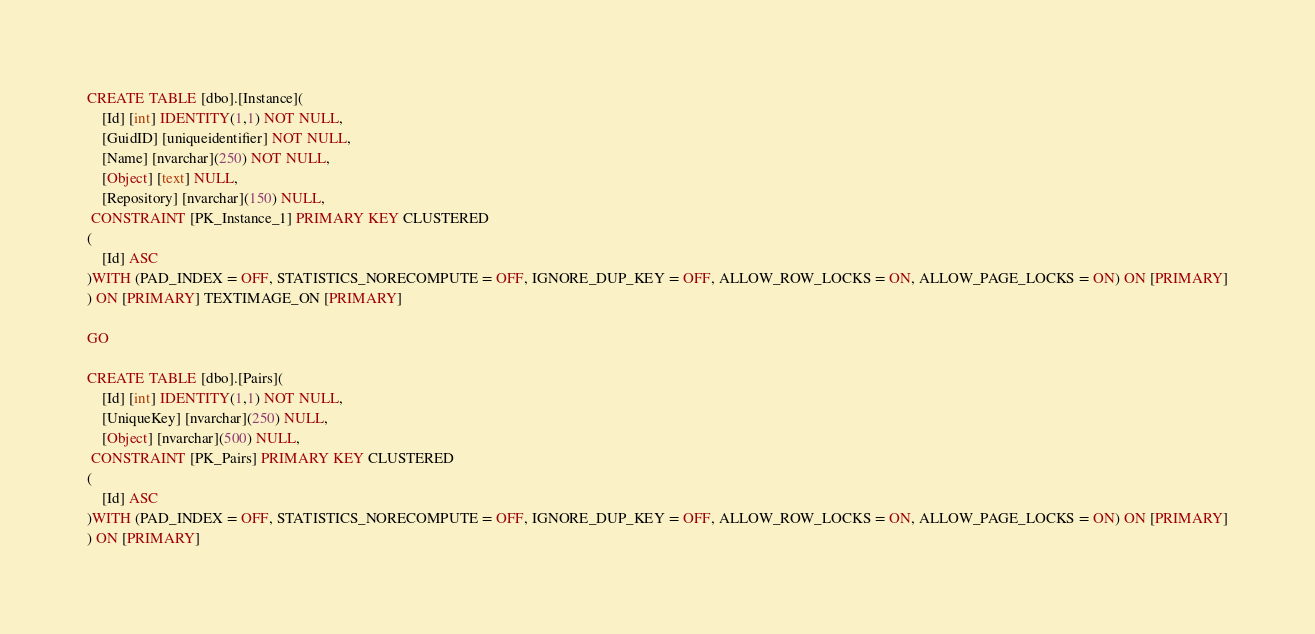Convert code to text. <code><loc_0><loc_0><loc_500><loc_500><_SQL_>CREATE TABLE [dbo].[Instance](
	[Id] [int] IDENTITY(1,1) NOT NULL,
	[GuidID] [uniqueidentifier] NOT NULL,
	[Name] [nvarchar](250) NOT NULL,
	[Object] [text] NULL,
	[Repository] [nvarchar](150) NULL,
 CONSTRAINT [PK_Instance_1] PRIMARY KEY CLUSTERED 
(
	[Id] ASC
)WITH (PAD_INDEX = OFF, STATISTICS_NORECOMPUTE = OFF, IGNORE_DUP_KEY = OFF, ALLOW_ROW_LOCKS = ON, ALLOW_PAGE_LOCKS = ON) ON [PRIMARY]
) ON [PRIMARY] TEXTIMAGE_ON [PRIMARY]

GO

CREATE TABLE [dbo].[Pairs](
	[Id] [int] IDENTITY(1,1) NOT NULL,
	[UniqueKey] [nvarchar](250) NULL,
	[Object] [nvarchar](500) NULL,
 CONSTRAINT [PK_Pairs] PRIMARY KEY CLUSTERED 
(
	[Id] ASC
)WITH (PAD_INDEX = OFF, STATISTICS_NORECOMPUTE = OFF, IGNORE_DUP_KEY = OFF, ALLOW_ROW_LOCKS = ON, ALLOW_PAGE_LOCKS = ON) ON [PRIMARY]
) ON [PRIMARY]</code> 